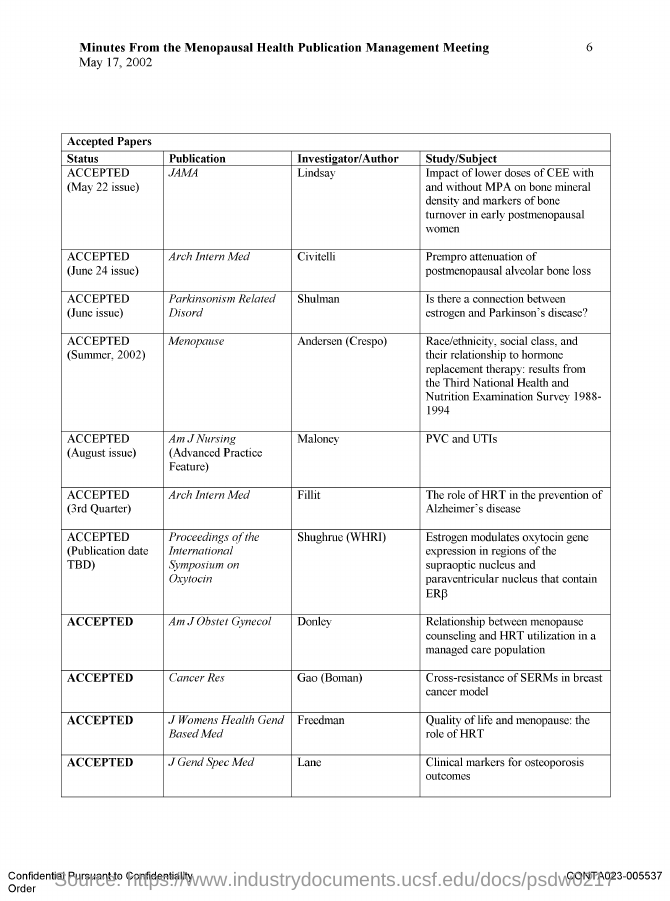What is the document about?
Offer a very short reply. Minutes From the Menopausal Health Publication Management Meeting. When is the document dated?
Keep it short and to the point. May 17, 2002. What is the study by Civitelli?
Provide a succinct answer. Prempro attenuation of postmenopausal alveolar bone loss. Who has authored "Is there a connection between estrogen and Parkinson's disease"?
Offer a terse response. Shulman. In which publication PVC and UTIs has been published?
Offer a very short reply. Am J Nursing (Advanced Practice Feature). What is the status of "Cross-resistance of SERMs in breast cancer model" ?
Your answer should be compact. Accepted. 